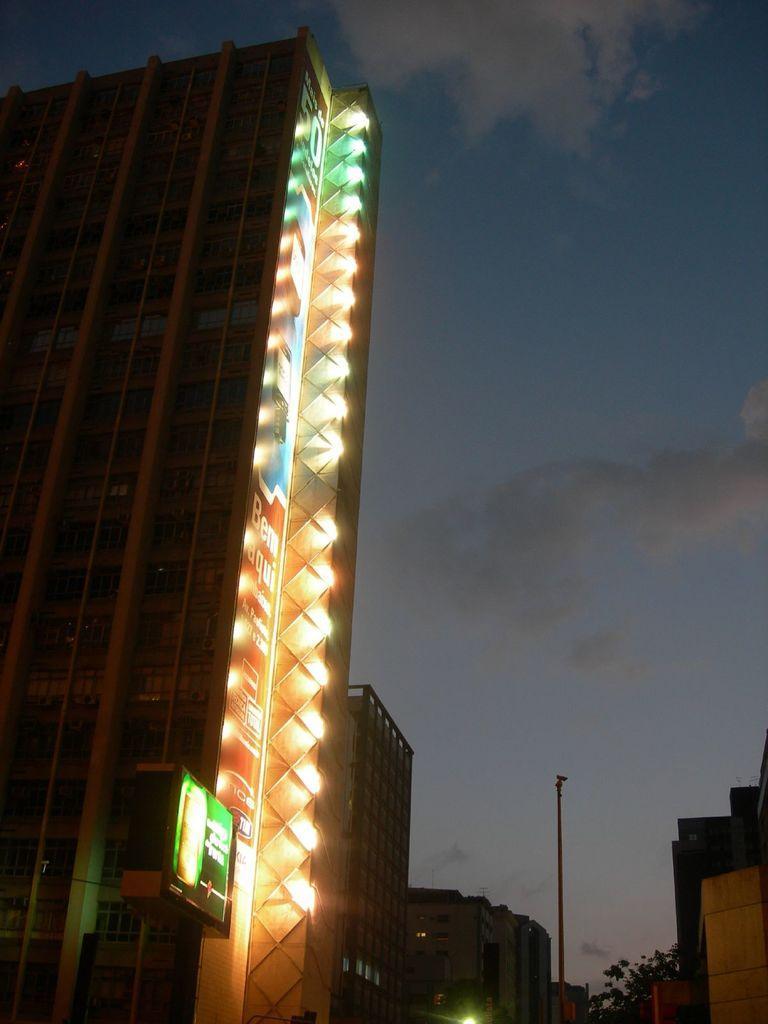How would you summarize this image in a sentence or two? In this image we can see a building with lights on the left side and there is a board with an image. We can also see some buildings and there is a tree in the background and we can see the sky with clouds at the top. 